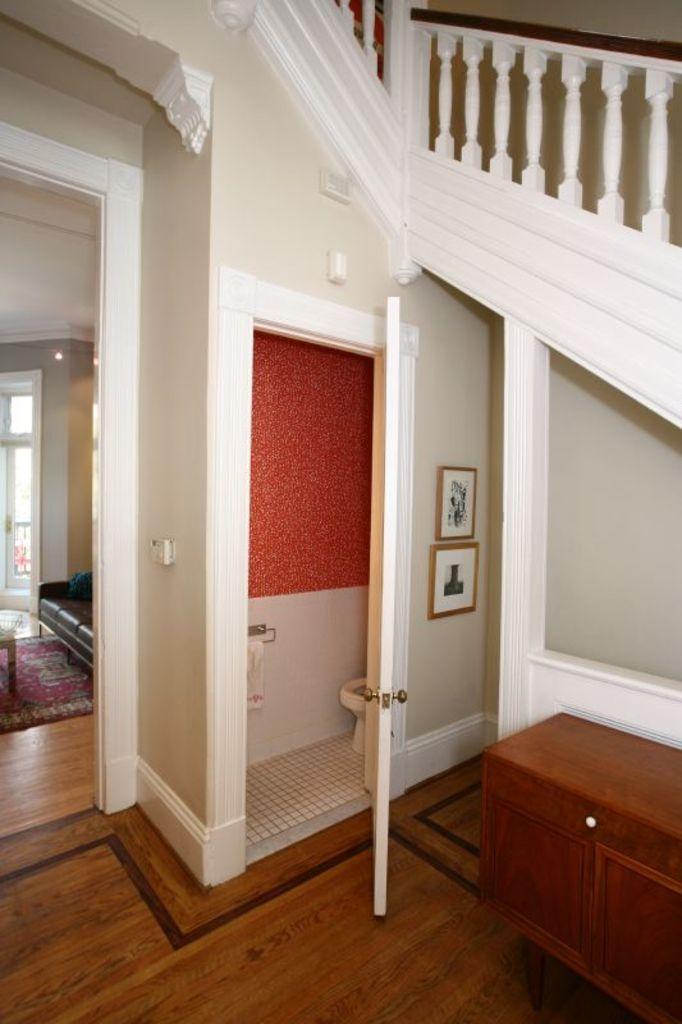Could you give a brief overview of what you see in this image? This picture is taken in inside of the house, in this image in the foreground there is a table, door, toilet, towel and some photo frames on the wall. On the left side there is a couch, window, carpet. At the bottom there is floor and at the top there is railing. 